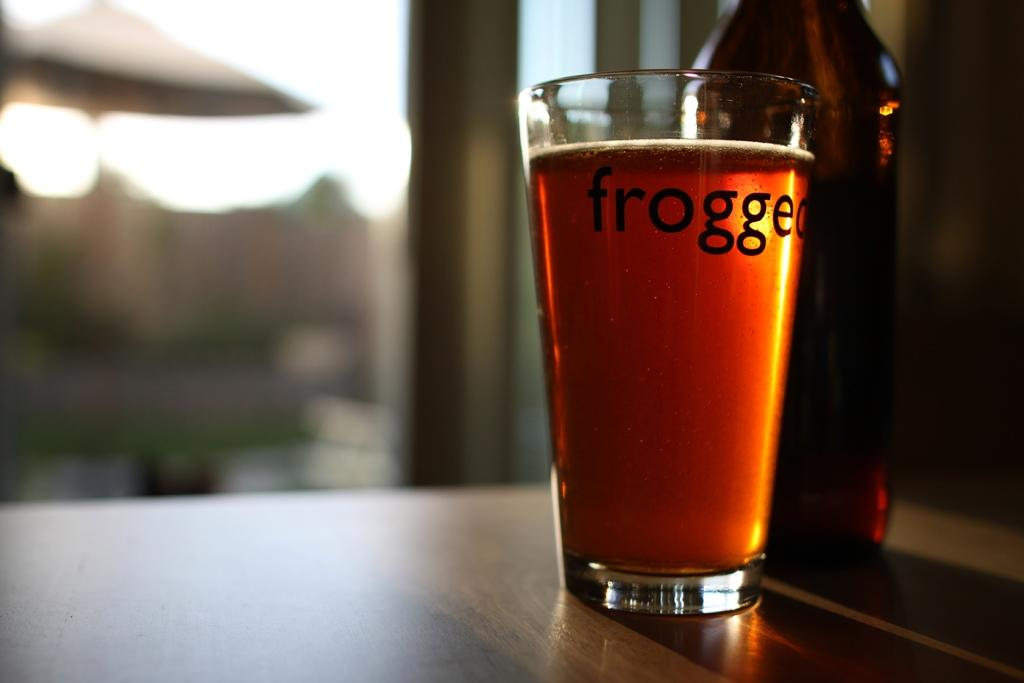<image>
Offer a succinct explanation of the picture presented. Full cup of beer with the word frogged on it. 